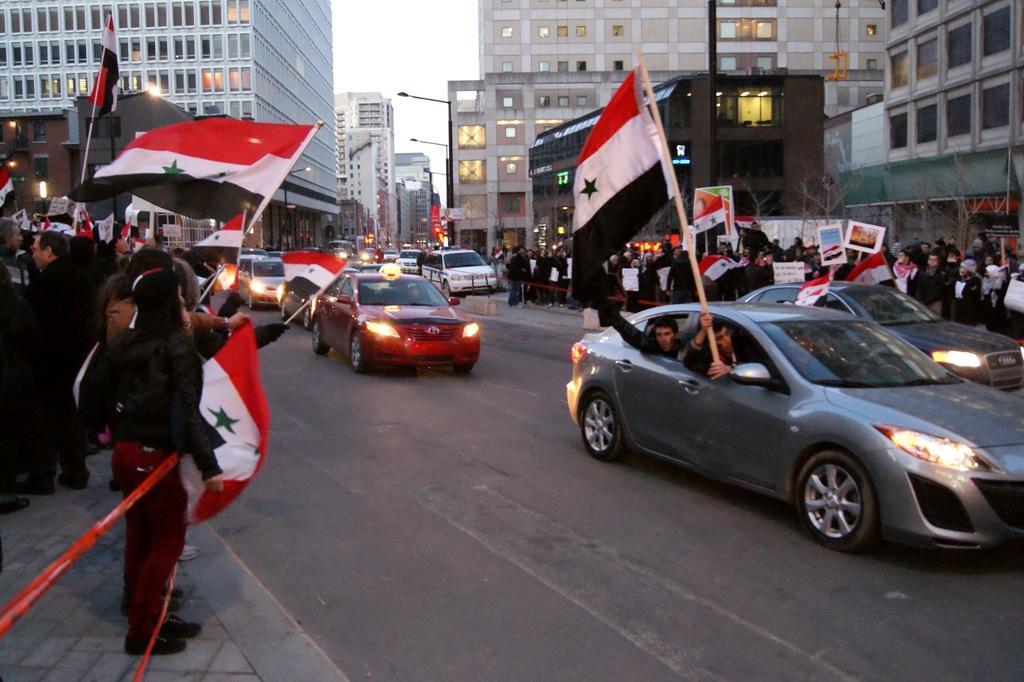Please provide a concise description of this image. This picture is clicked outside the city. Here, we see cars moving on the road. On either side of the road, we see people standing on the sideways and holding flags and boards in their hands. These flags are in red, white and green color. In the background, there are many buildings and at the top of the picture, we see the sky. 